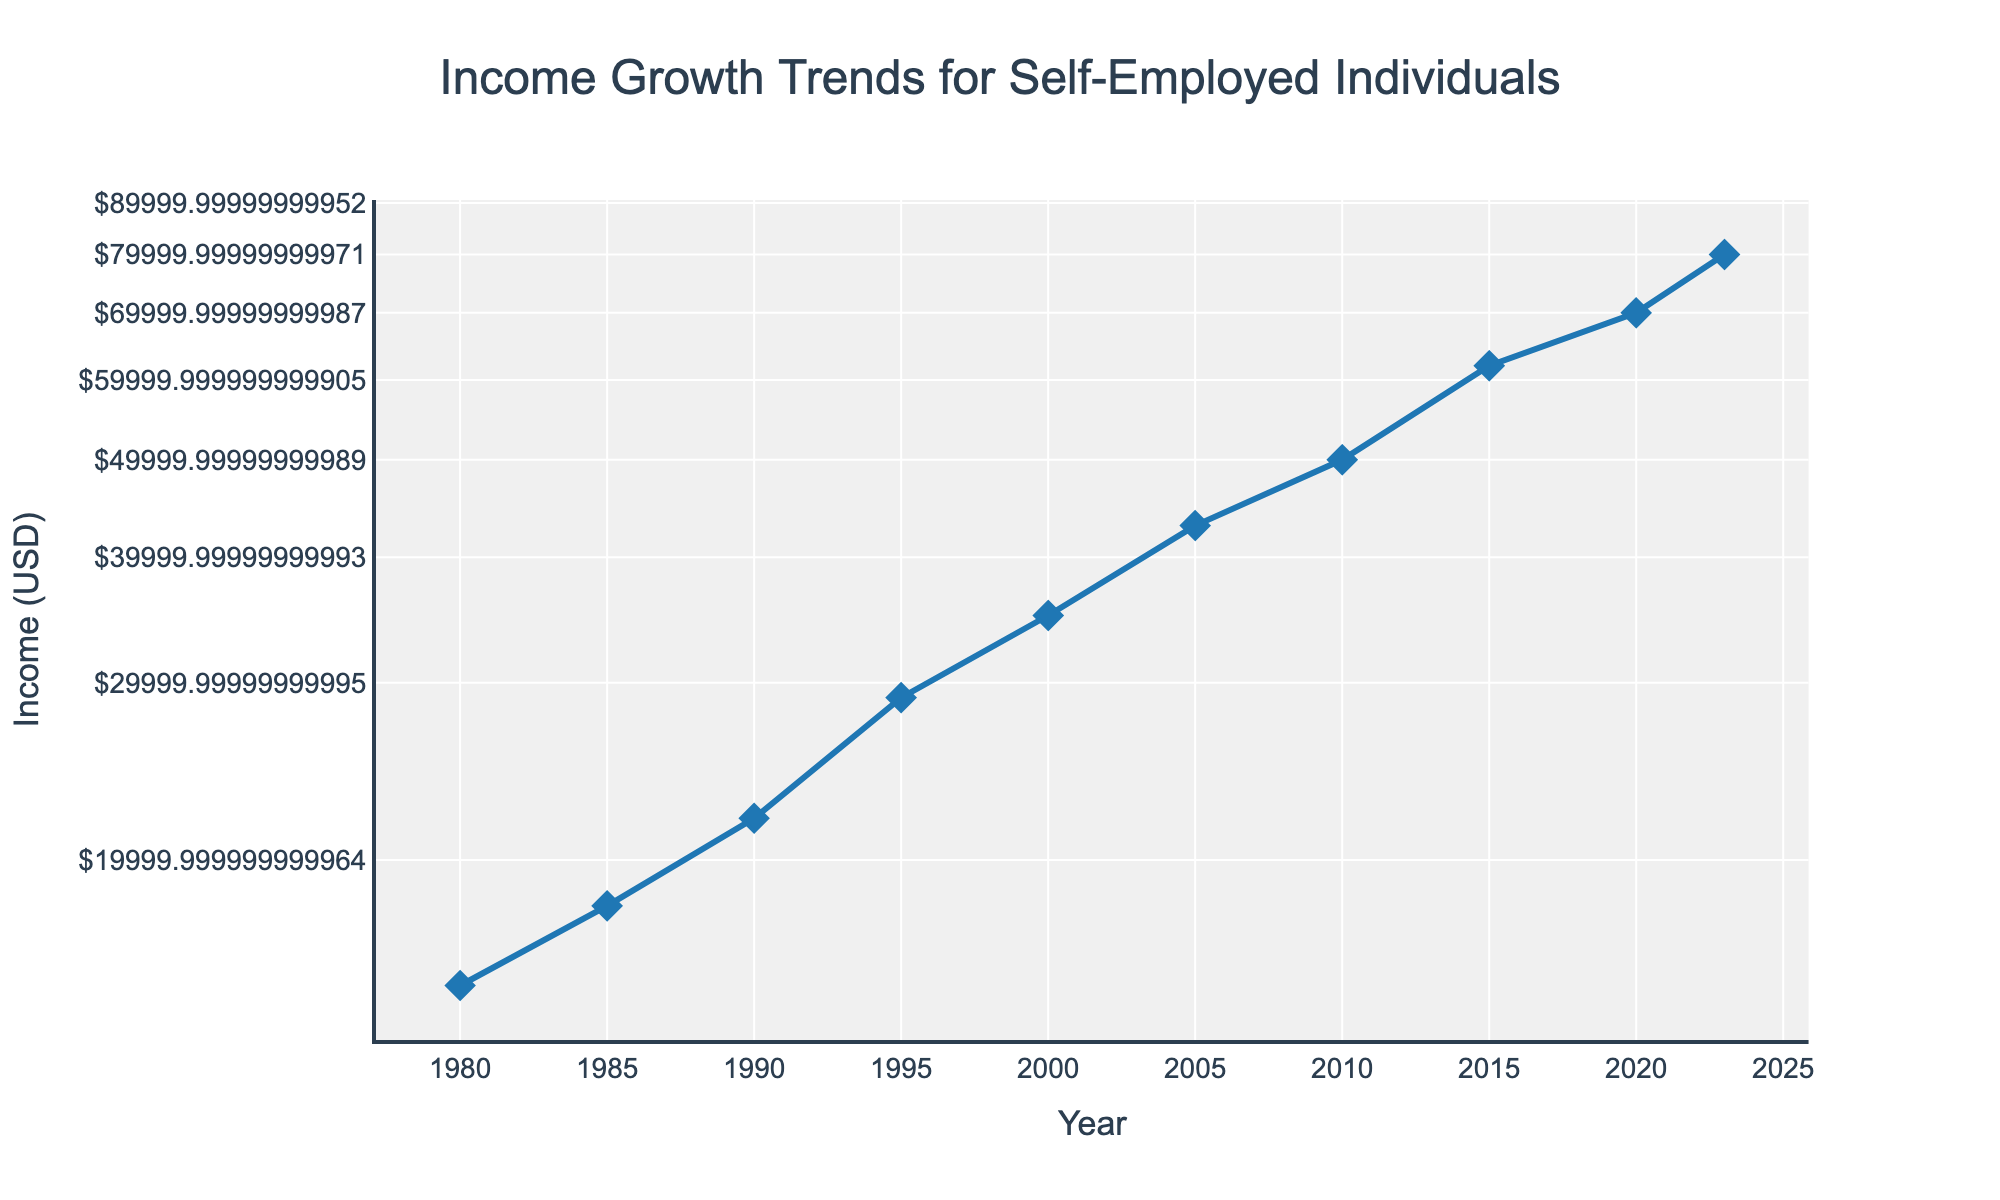What is the title of the plot? The title is displayed at the top of the figure and serves as a summary of what the plot represents. It reads "Income Growth Trends for Self-Employed Individuals".
Answer: Income Growth Trends for Self-Employed Individuals What is the vertical axis title? The title of the vertical axis indicates what data is being measured, which is "Income (USD)".
Answer: Income (USD) What is the trend of income for self-employed individuals from 1980 to 2023? To identify the trend, observe the overall direction of the line connecting the data points from 1980 to 2023 on the plot. It consistently increases, indicating an upward trend in income.
Answer: Upward trend In which year did the income exceed $50,000 for the first time? Look for the first data point where the y-value (income) surpasses $50,000. This occurs between 2005 and 2010, specifically in the year 2010.
Answer: 2010 How does the income in 2023 compare to that in 1980? Compare the y-values for the years 2023 and 1980. The income in 2023 is significantly higher than in 1980.
Answer: Higher Which year shows the greatest increase in income from the previous year? Calculate the differences in income between consecutive years and identify the largest difference. The biggest jump is from 1990 ($22,000) to 1995 ($29,000), an increase of $7,000.
Answer: 1995 What type of scale is used for the y-axis? Observing the y-axis ticks changing multiplicatively and the axis label type, we can tell it is a logarithmic scale.
Answer: Logarithmic scale What is the income value for the year 2000? Look at the y-value corresponding to the year 2000 on the plot. The income for that year is $35,000.
Answer: $35,000 How many data points are there on the plot? Count the number of distinct points marked by symbols on the line plot. There are 10 data points.
Answer: 10 Calculate the average annual income for the time span shown in the plot. Add all annual incomes from the data and divide by the total number of years (10). ($15,000 + $18,000 + $22,000 + $29,000 + $35,000 + $43,000 + $50,000 + $62,000 + $70,000 + $80,000) / 10 = $42,400.
Answer: $42,400 